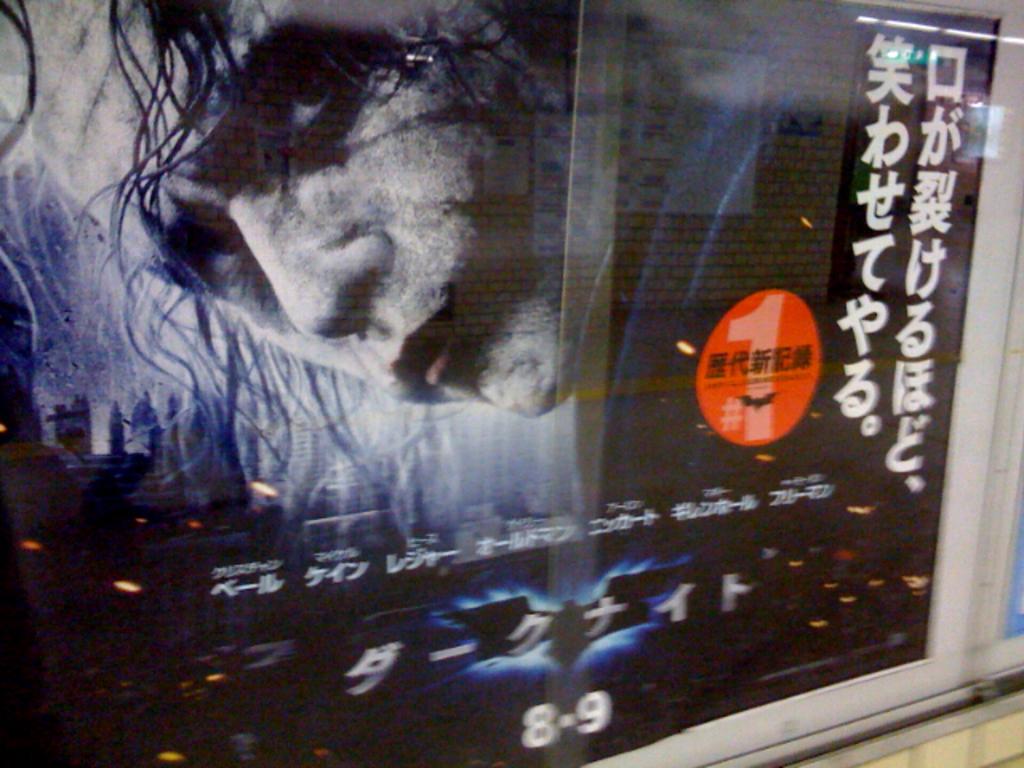What two numbers are shown on the bottom of this sign?
Offer a terse response. 8-9. 